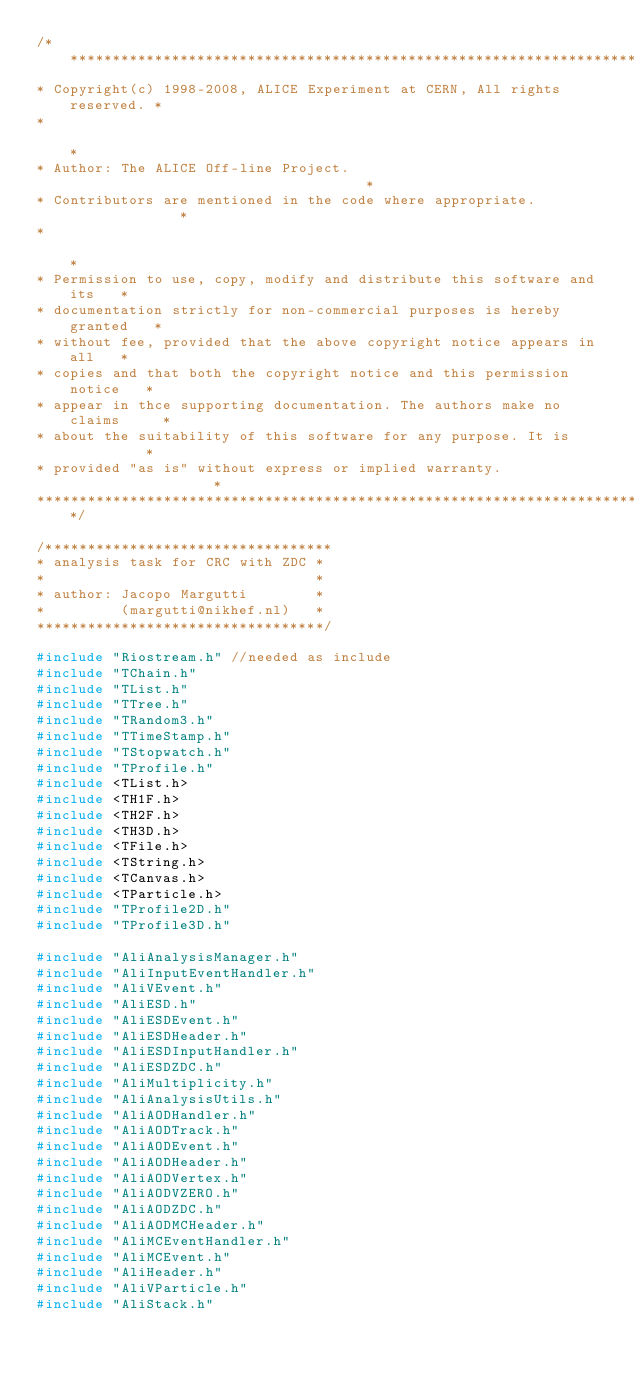Convert code to text. <code><loc_0><loc_0><loc_500><loc_500><_C++_>/**************************************************************************
* Copyright(c) 1998-2008, ALICE Experiment at CERN, All rights reserved. *
*                                                                        *
* Author: The ALICE Off-line Project.                                    *
* Contributors are mentioned in the code where appropriate.              *
*                                                                        *
* Permission to use, copy, modify and distribute this software and its   *
* documentation strictly for non-commercial purposes is hereby granted   *
* without fee, provided that the above copyright notice appears in all   *
* copies and that both the copyright notice and this permission notice   *
* appear in thce supporting documentation. The authors make no claims     *
* about the suitability of this software for any purpose. It is          *
* provided "as is" without express or implied warranty.                  *
**************************************************************************/

/**********************************
* analysis task for CRC with ZDC *
*                                *
* author: Jacopo Margutti        *
*         (margutti@nikhef.nl)   *
**********************************/

#include "Riostream.h" //needed as include
#include "TChain.h"
#include "TList.h"
#include "TTree.h"
#include "TRandom3.h"
#include "TTimeStamp.h"
#include "TStopwatch.h"
#include "TProfile.h"
#include <TList.h>
#include <TH1F.h>
#include <TH2F.h>
#include <TH3D.h>
#include <TFile.h>
#include <TString.h>
#include <TCanvas.h>
#include <TParticle.h>
#include "TProfile2D.h"
#include "TProfile3D.h"

#include "AliAnalysisManager.h"
#include "AliInputEventHandler.h"
#include "AliVEvent.h"
#include "AliESD.h"
#include "AliESDEvent.h"
#include "AliESDHeader.h"
#include "AliESDInputHandler.h"
#include "AliESDZDC.h"
#include "AliMultiplicity.h"
#include "AliAnalysisUtils.h"
#include "AliAODHandler.h"
#include "AliAODTrack.h"
#include "AliAODEvent.h"
#include "AliAODHeader.h"
#include "AliAODVertex.h"
#include "AliAODVZERO.h"
#include "AliAODZDC.h"
#include "AliAODMCHeader.h"
#include "AliMCEventHandler.h"
#include "AliMCEvent.h"
#include "AliHeader.h"
#include "AliVParticle.h"
#include "AliStack.h"</code> 